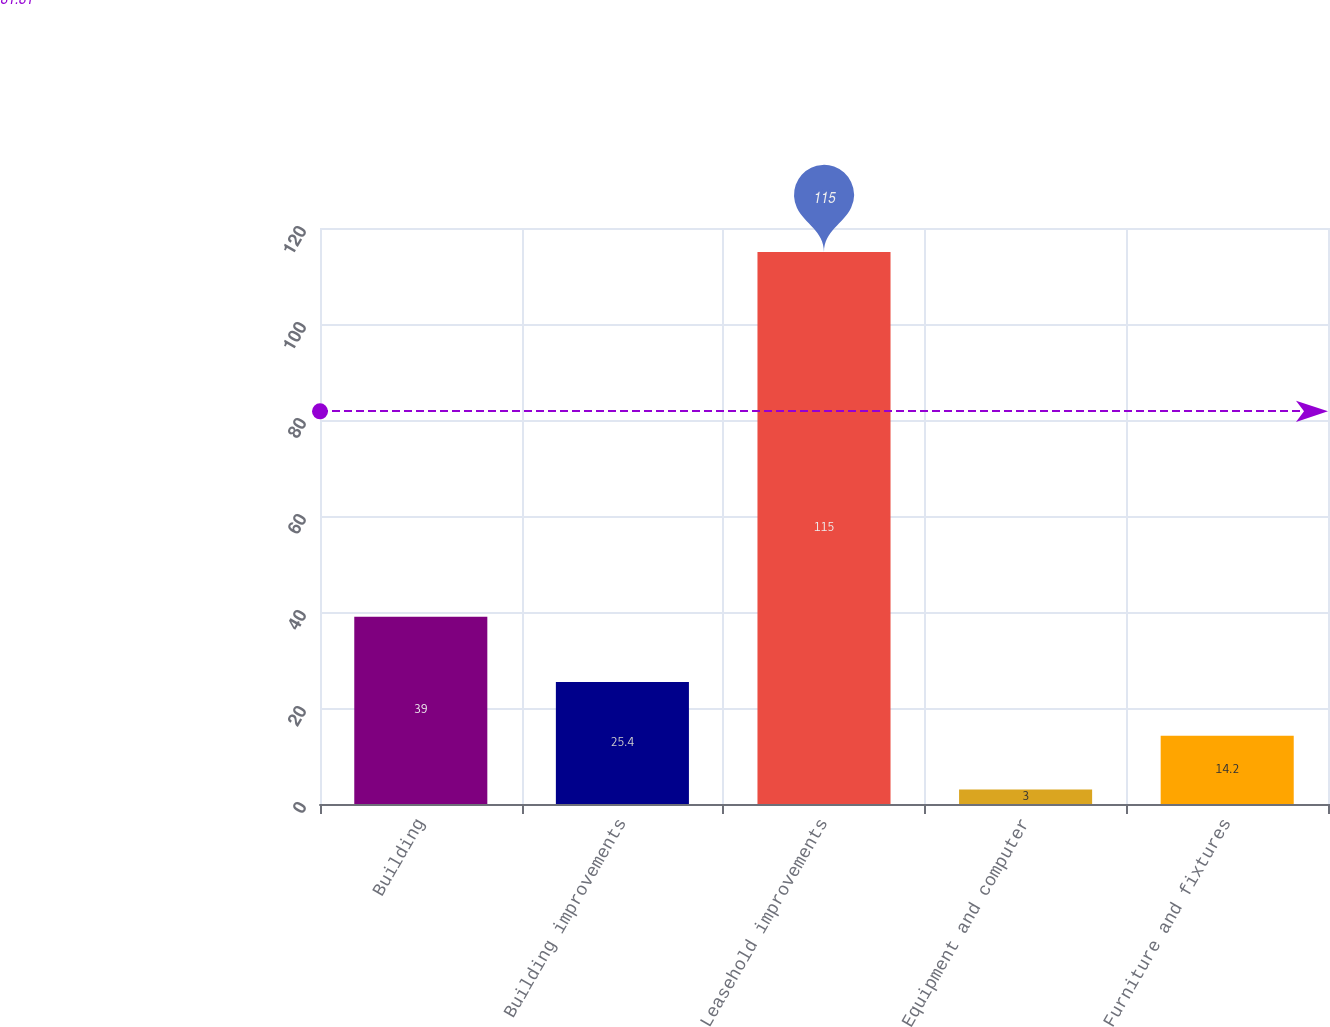<chart> <loc_0><loc_0><loc_500><loc_500><bar_chart><fcel>Building<fcel>Building improvements<fcel>Leasehold improvements<fcel>Equipment and computer<fcel>Furniture and fixtures<nl><fcel>39<fcel>25.4<fcel>115<fcel>3<fcel>14.2<nl></chart> 